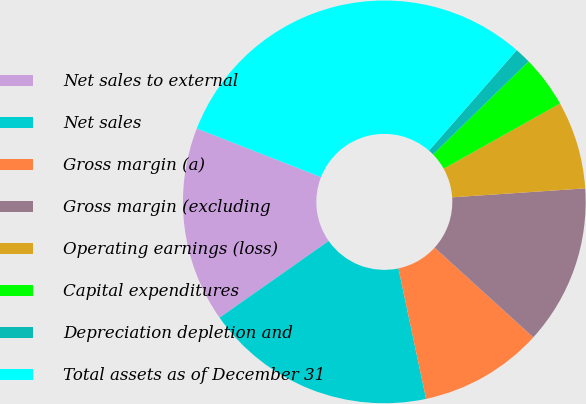<chart> <loc_0><loc_0><loc_500><loc_500><pie_chart><fcel>Net sales to external<fcel>Net sales<fcel>Gross margin (a)<fcel>Gross margin (excluding<fcel>Operating earnings (loss)<fcel>Capital expenditures<fcel>Depreciation depletion and<fcel>Total assets as of December 31<nl><fcel>15.69%<fcel>18.57%<fcel>9.93%<fcel>12.81%<fcel>7.05%<fcel>4.17%<fcel>1.29%<fcel>30.48%<nl></chart> 